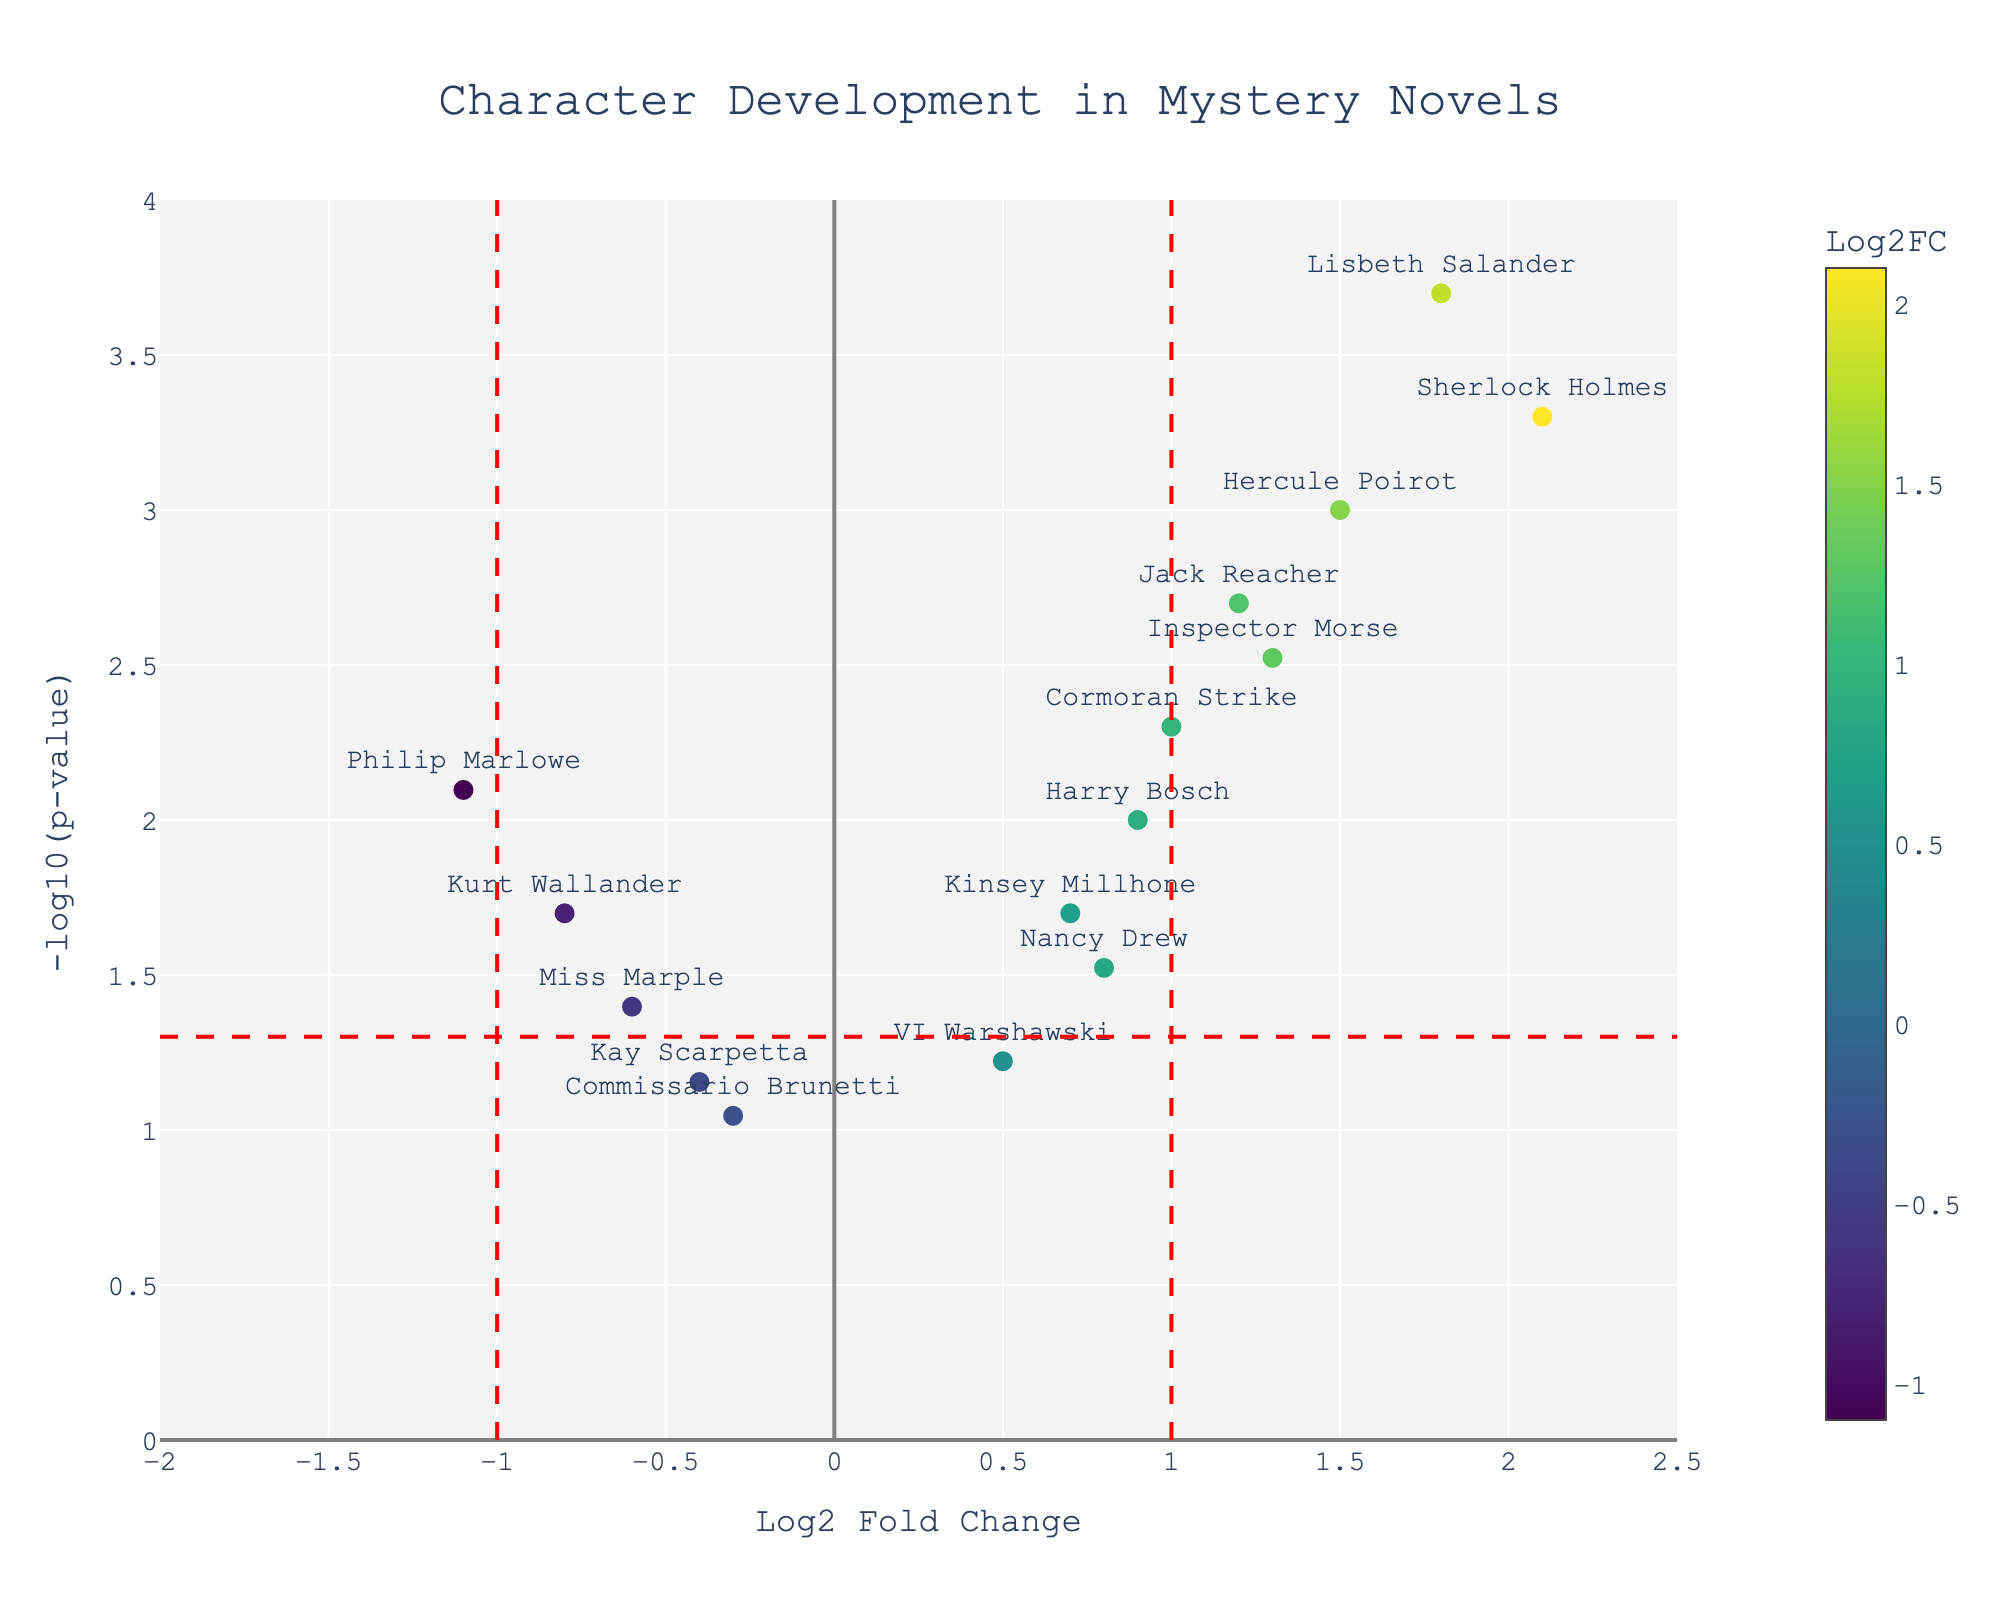How many characters are displayed in the figure? The figure displays data points, each representing a character. Counting the number of distinct characters listed around the data points gives us the total number.
Answer: 15 What is the title of the plot? The plot title is usually displayed prominently at the top of the figure. We observe the text there to identify it.
Answer: Character Development in Mystery Novels Which character has the highest -log10(p-value) in the figure? By looking for the character with the highest point on the y-axis (-log10(p-value)), we determine the character.
Answer: Lisbeth Salander Which character has the most negative Log2FC and what is its value? To find the character with the most negative Log2FC, we look for the point furthest to the left on the x-axis and read the associated character and its Log2FC value.
Answer: Philip Marlowe, -1.1 What are the Log2FC values for central characters like Hercule Poirot and Sherlock Holmes? Identify the points labeled with these characters and read the corresponding Log2FC values from the x-axis.
Answer: Hercule Poirot: 1.5, Sherlock Holmes: 2.1 How many characters have a fold change (Log2FC) greater than 1? To find the characters with Log2FC > 1, count the number of points to the right of x=1 line.
Answer: 6 What does the red vertical line at x=1 represent? The red vertical line typically separates significant positive fold changes. The x=1 line indicates characters with Log2FC of 1 or greater.
Answer: Threshold for positive Log2 Fold Change Who's the character closest to the horizontal significance threshold line and what is their -log10(p-value)? Identify the character closest to the y=-log10(0.05) line to determine the p-value significance.
Answer: Miss Marple, -log10(p-value) ≈ 1.3 Compare the p-values of Harry Bosch and Kurt Wallander. Who has the more statistically significant impact and what logical reasoning supports your answer? Harry Bosch and Kurt Wallander's significance comparison requires finding -log10(p-value) from the y-axis. Higher values indicate higher significance. Harry Bosch has a higher -log10(p-value) than Kurt Wallander, indicating higher significance.
Answer: Harry Bosch: more significant What can we infer about characters below the horizontal red line in terms of statistical significance? Characters below the red horizontal line have p-values higher than 0.05, indicating they are not statistically significant. This is inferred since -log10(0.05) marks the significance threshold.
Answer: Not statistically significant 